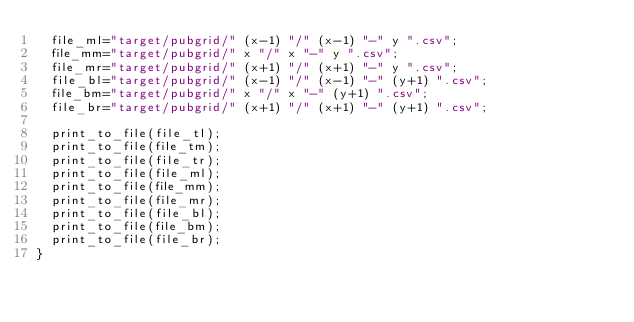Convert code to text. <code><loc_0><loc_0><loc_500><loc_500><_Awk_>  file_ml="target/pubgrid/" (x-1) "/" (x-1) "-" y ".csv";
  file_mm="target/pubgrid/" x "/" x "-" y ".csv";
  file_mr="target/pubgrid/" (x+1) "/" (x+1) "-" y ".csv";
  file_bl="target/pubgrid/" (x-1) "/" (x-1) "-" (y+1) ".csv";
  file_bm="target/pubgrid/" x "/" x "-" (y+1) ".csv";
  file_br="target/pubgrid/" (x+1) "/" (x+1) "-" (y+1) ".csv";

  print_to_file(file_tl);
  print_to_file(file_tm);
  print_to_file(file_tr);
  print_to_file(file_ml);
  print_to_file(file_mm);
  print_to_file(file_mr);
  print_to_file(file_bl);
  print_to_file(file_bm);
  print_to_file(file_br);
}</code> 